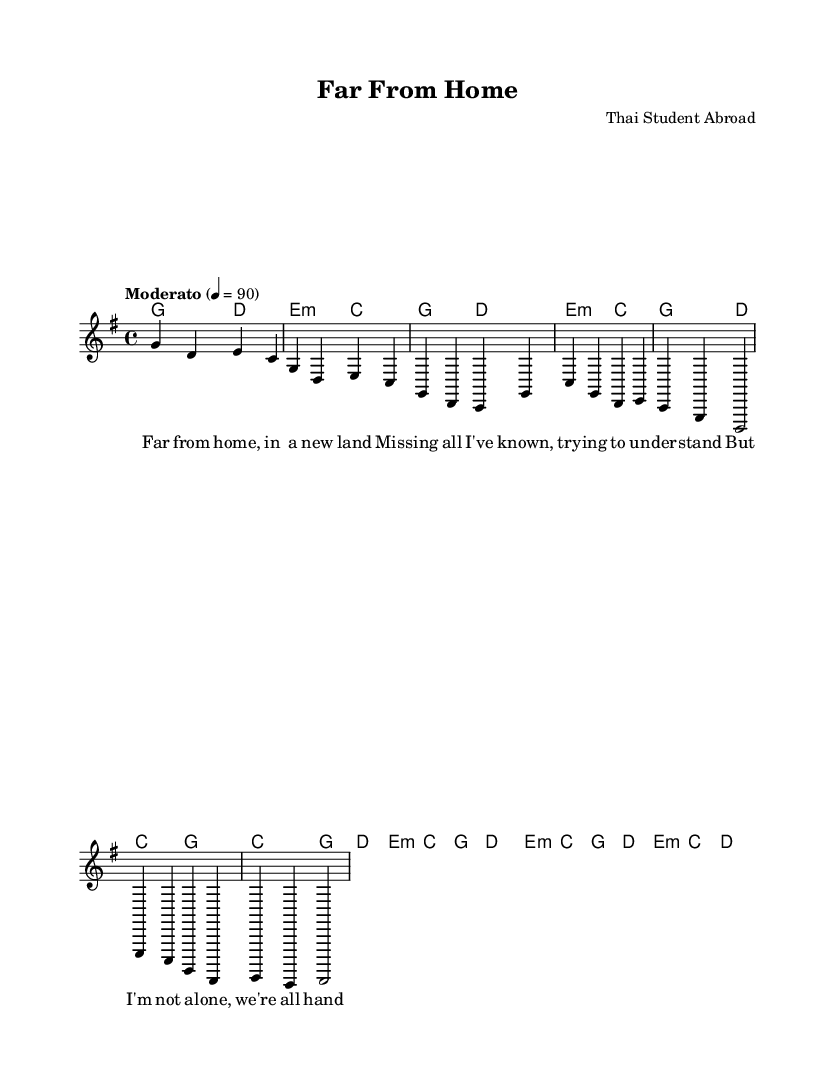What is the key signature of this music? The key signature is G major, which has one sharp (F#). This is determined by looking at the key signature placed at the beginning of the sheet music.
Answer: G major What is the time signature of this music? The time signature is 4/4, as indicated at the beginning of the score. This means there are four beats in each measure and the quarter note receives one beat.
Answer: 4/4 What is the tempo marking for this piece? The tempo marking is "Moderato," which suggests a moderate pace for the performance. This is found at the beginning of the score as a directive for how fast to play the piece.
Answer: Moderato How many measures are in the melody? The melody contains 8 measures, as counted from the start of the introductory line through all sections presented in the music.
Answer: 8 measures What chord starts the bridge section? The bridge section begins with an E minor chord, which can be identified from the chords listed at the start of the bridge in the harmonies part.
Answer: E minor How does the chorus relate to the verse in terms of structure? The chorus is shorter than the verse, with a different melodic line and a simpler harmony structure, which is characteristic of folk-pop ballads aiming to emphasize the main theme. This is analyzed by comparing the lengths and musical phrases of both sections.
Answer: Shorter structure What is the theme of the lyrics presented in the score? The theme of the lyrics revolves around feelings of nostalgia and adaptation associated with being far from home, highlighted by phrases such as "Far from home" and "Trying to understand." This is understood by reading the lyrics provided and determining their emotional context.
Answer: Nostalgia and adaptation 